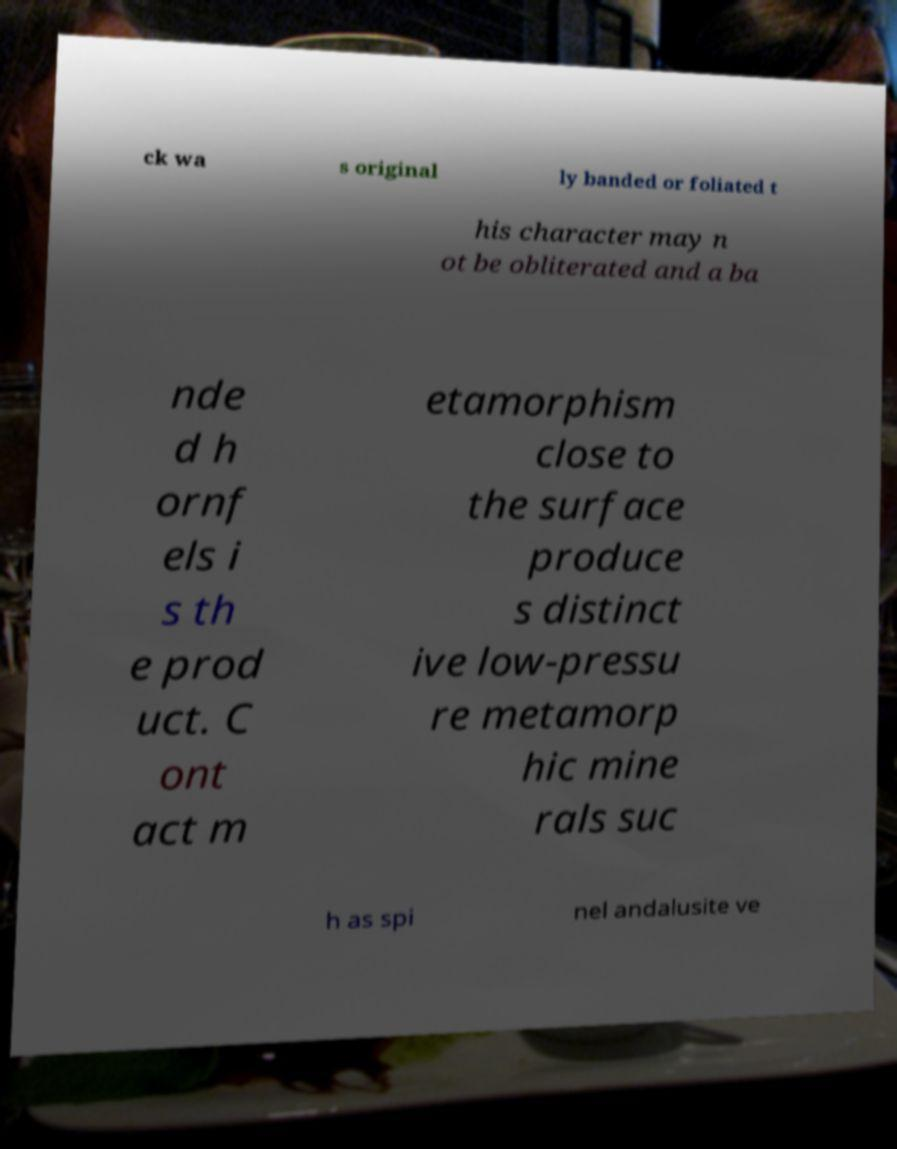Can you accurately transcribe the text from the provided image for me? ck wa s original ly banded or foliated t his character may n ot be obliterated and a ba nde d h ornf els i s th e prod uct. C ont act m etamorphism close to the surface produce s distinct ive low-pressu re metamorp hic mine rals suc h as spi nel andalusite ve 